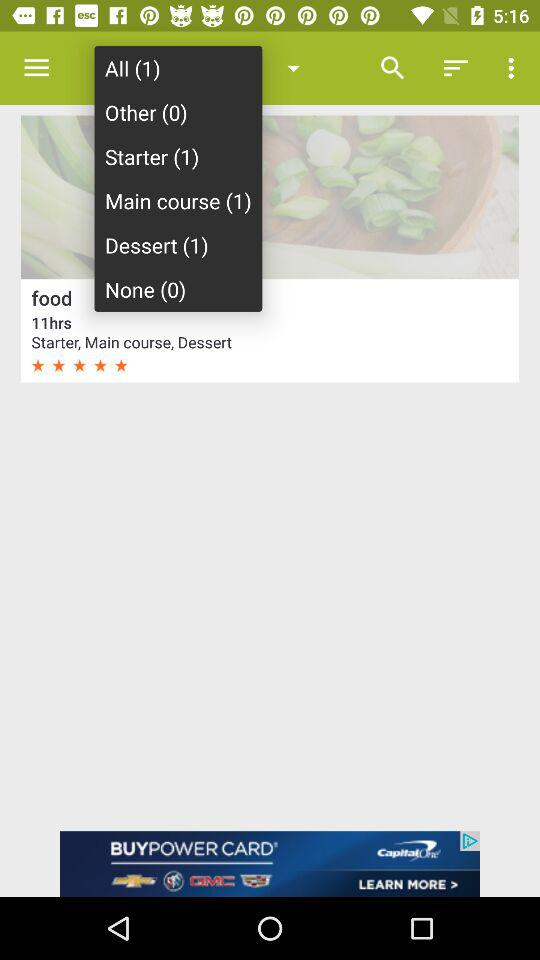What is the rating? The rating is 5 stars. 